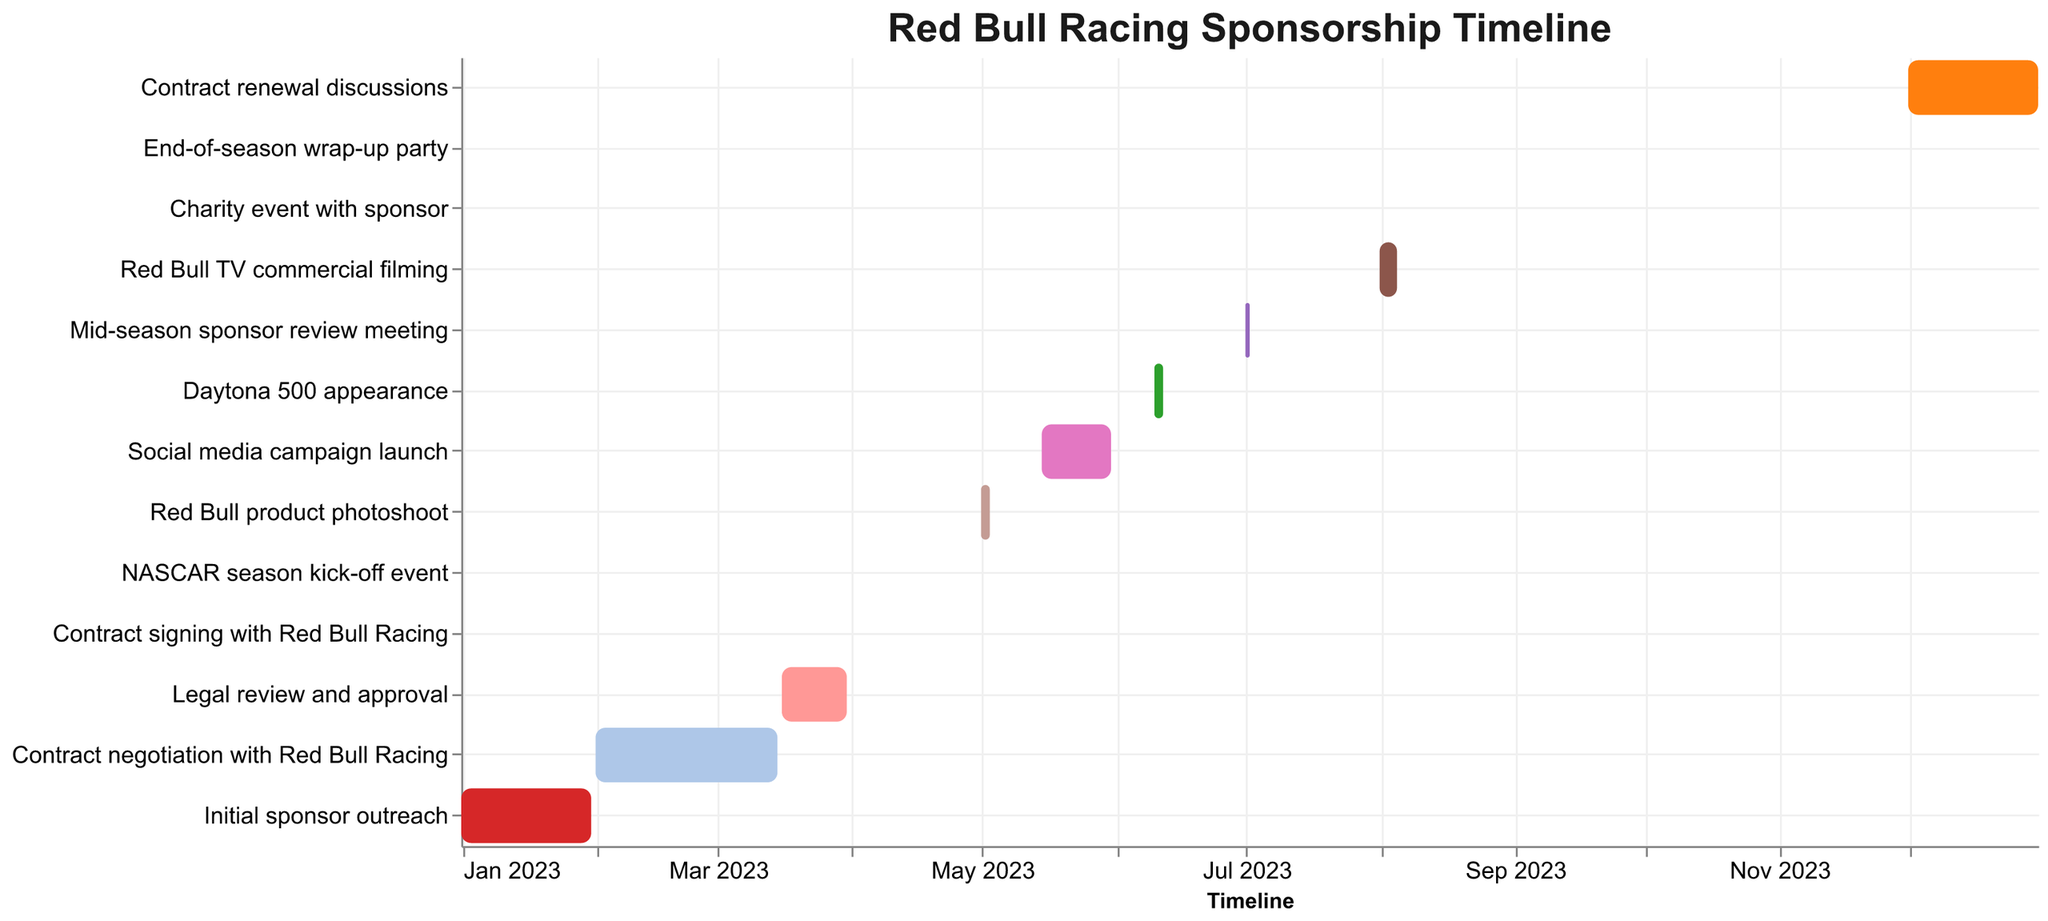What is the title of the chart? The title of the chart is displayed at the top and reads "Red Bull Racing Sponsorship Timeline".
Answer: Red Bull Racing Sponsorship Timeline Which task takes place in May 2023? By looking at the Gantt chart, the tasks with a bar in May 2023 are "Red Bull product photoshoot" and "Social media campaign launch". These tasks are displayed with bars spanning dates in that month.
Answer: Red Bull product photoshoot and Social media campaign launch How long did contract negotiation with Red Bull Racing last? The "Contract negotiation with Red Bull Racing" starts on February 1, 2023, and ends on March 15, 2023. The length of this period is calculated by counting the days between these two dates.
Answer: 43 days Which task immediately follows the Daytona 500 appearance? To find this, check the end date of "Daytona 500 appearance" which is June 12, 2023. The next task after this date is "Mid-season sponsor review meeting" starting on July 1, 2023.
Answer: Mid-season sponsor review meeting How many tasks are completed by the end of March 2023? Analyzing the tasks ending by March 31, 2023, we see "Initial sponsor outreach" (January 31), "Contract negotiation with Red Bull Racing" (March 15), and "Legal review and approval" (March 31). There are three tasks completed by then.
Answer: 3 Which task has the shortest duration? The "Contract signing with Red Bull Racing" and several other events such as the "NASCAR season kick-off event" each occur on a single day. The shortest duration is thus one day.
Answer: Contract signing with Red Bull Racing, NASCAR season kick-off event, Charity event with sponsor, End-of-season wrap-up party What tasks are related to promotional activities? The tasks that involve promotional activities include "Red Bull product photoshoot", "Social media campaign launch", "Daytona 500 appearance", and "Red Bull TV commercial filming". These events are identifiable as promotional based on their descriptions.
Answer: Red Bull product photoshoot, Social media campaign launch, Daytona 500 appearance, Red Bull TV commercial filming When does the contract renewal discussion begin? By locating the "Contract renewal discussions" task, we see that it begins on December 1, 2023.
Answer: December 1, 2023 What is the duration of the Social media campaign launch? The "Social media campaign launch" begins on May 15, 2023, and ends on May 31, 2023. Counting the days between these dates gives us the duration of this task.
Answer: 16 days Which task spans the longest time and what is its duration? The task with the longest bar is "Contract renewal discussions," starting on December 1, 2023, and ending on December 31, 2023. The duration can be computed by counting the days between these two dates.
Answer: Contract renewal discussions, 31 days 